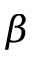Convert formula to latex. <formula><loc_0><loc_0><loc_500><loc_500>\beta</formula> 